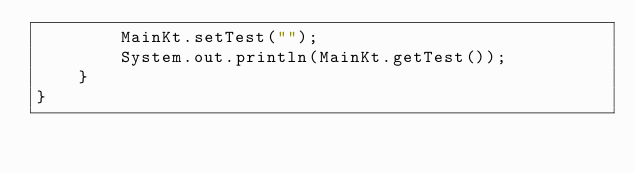Convert code to text. <code><loc_0><loc_0><loc_500><loc_500><_Java_>        MainKt.setTest("");
        System.out.println(MainKt.getTest());
    }
}
</code> 